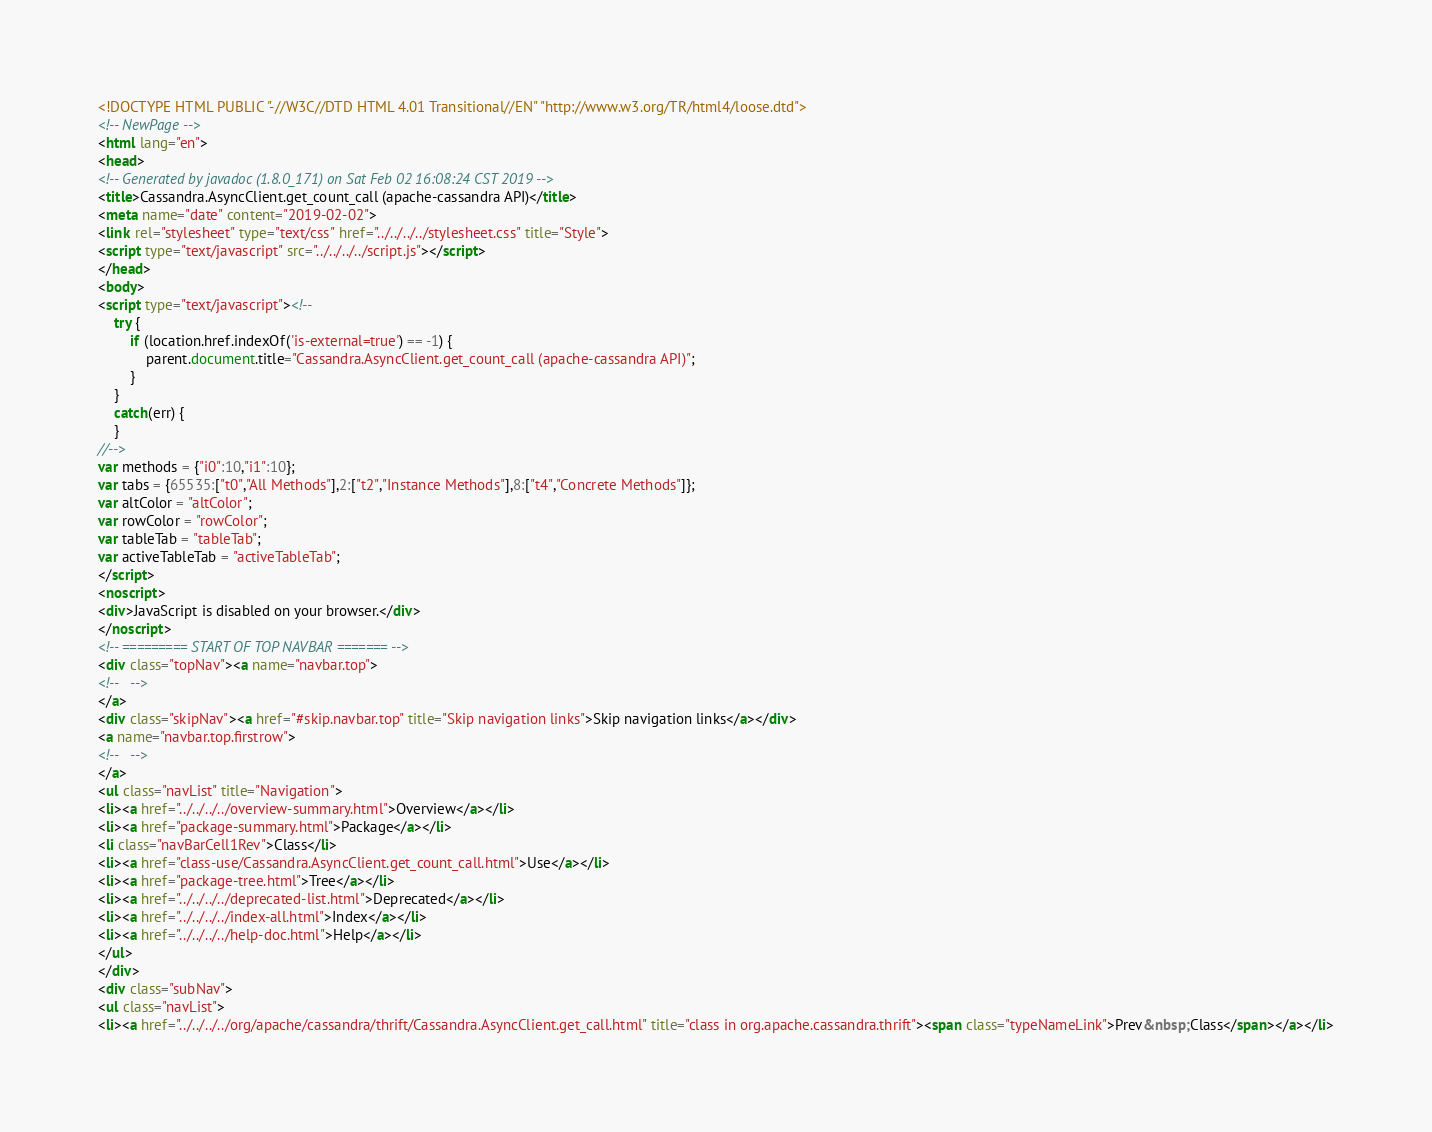Convert code to text. <code><loc_0><loc_0><loc_500><loc_500><_HTML_><!DOCTYPE HTML PUBLIC "-//W3C//DTD HTML 4.01 Transitional//EN" "http://www.w3.org/TR/html4/loose.dtd">
<!-- NewPage -->
<html lang="en">
<head>
<!-- Generated by javadoc (1.8.0_171) on Sat Feb 02 16:08:24 CST 2019 -->
<title>Cassandra.AsyncClient.get_count_call (apache-cassandra API)</title>
<meta name="date" content="2019-02-02">
<link rel="stylesheet" type="text/css" href="../../../../stylesheet.css" title="Style">
<script type="text/javascript" src="../../../../script.js"></script>
</head>
<body>
<script type="text/javascript"><!--
    try {
        if (location.href.indexOf('is-external=true') == -1) {
            parent.document.title="Cassandra.AsyncClient.get_count_call (apache-cassandra API)";
        }
    }
    catch(err) {
    }
//-->
var methods = {"i0":10,"i1":10};
var tabs = {65535:["t0","All Methods"],2:["t2","Instance Methods"],8:["t4","Concrete Methods"]};
var altColor = "altColor";
var rowColor = "rowColor";
var tableTab = "tableTab";
var activeTableTab = "activeTableTab";
</script>
<noscript>
<div>JavaScript is disabled on your browser.</div>
</noscript>
<!-- ========= START OF TOP NAVBAR ======= -->
<div class="topNav"><a name="navbar.top">
<!--   -->
</a>
<div class="skipNav"><a href="#skip.navbar.top" title="Skip navigation links">Skip navigation links</a></div>
<a name="navbar.top.firstrow">
<!--   -->
</a>
<ul class="navList" title="Navigation">
<li><a href="../../../../overview-summary.html">Overview</a></li>
<li><a href="package-summary.html">Package</a></li>
<li class="navBarCell1Rev">Class</li>
<li><a href="class-use/Cassandra.AsyncClient.get_count_call.html">Use</a></li>
<li><a href="package-tree.html">Tree</a></li>
<li><a href="../../../../deprecated-list.html">Deprecated</a></li>
<li><a href="../../../../index-all.html">Index</a></li>
<li><a href="../../../../help-doc.html">Help</a></li>
</ul>
</div>
<div class="subNav">
<ul class="navList">
<li><a href="../../../../org/apache/cassandra/thrift/Cassandra.AsyncClient.get_call.html" title="class in org.apache.cassandra.thrift"><span class="typeNameLink">Prev&nbsp;Class</span></a></li></code> 